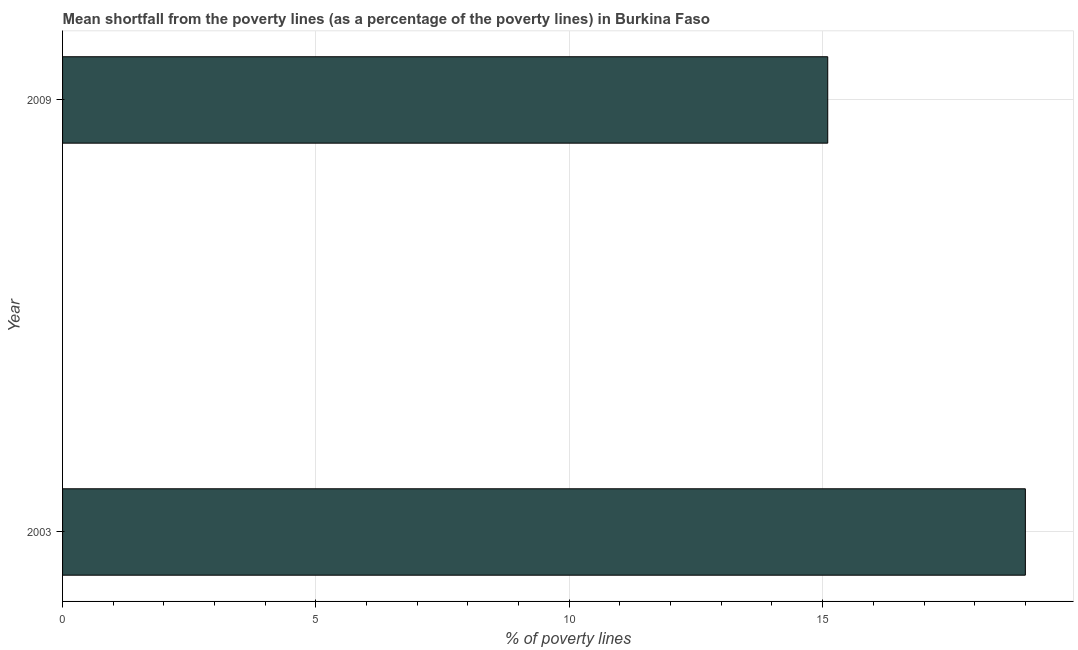Does the graph contain any zero values?
Your answer should be compact. No. Does the graph contain grids?
Keep it short and to the point. Yes. What is the title of the graph?
Offer a very short reply. Mean shortfall from the poverty lines (as a percentage of the poverty lines) in Burkina Faso. What is the label or title of the X-axis?
Your answer should be very brief. % of poverty lines. What is the label or title of the Y-axis?
Your response must be concise. Year. What is the poverty gap at national poverty lines in 2003?
Offer a very short reply. 19. Across all years, what is the minimum poverty gap at national poverty lines?
Your answer should be very brief. 15.1. In which year was the poverty gap at national poverty lines minimum?
Your response must be concise. 2009. What is the sum of the poverty gap at national poverty lines?
Keep it short and to the point. 34.1. What is the average poverty gap at national poverty lines per year?
Make the answer very short. 17.05. What is the median poverty gap at national poverty lines?
Offer a terse response. 17.05. What is the ratio of the poverty gap at national poverty lines in 2003 to that in 2009?
Your answer should be very brief. 1.26. Is the poverty gap at national poverty lines in 2003 less than that in 2009?
Your response must be concise. No. How many years are there in the graph?
Offer a terse response. 2. What is the % of poverty lines in 2009?
Keep it short and to the point. 15.1. What is the difference between the % of poverty lines in 2003 and 2009?
Make the answer very short. 3.9. What is the ratio of the % of poverty lines in 2003 to that in 2009?
Offer a terse response. 1.26. 